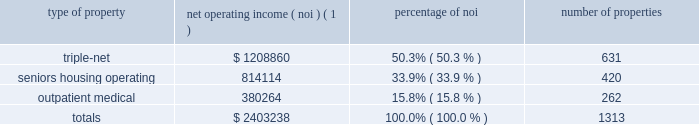Item 7 .
Management 2019s discussion and analysis of financial condition and results of operations the following discussion and analysis is based primarily on the consolidated financial statements of welltower inc .
For the periods presented and should be read together with the notes thereto contained in this annual report on form 10-k .
Other important factors are identified in 201citem 1 2014 business 201d and 201citem 1a 2014 risk factors 201d above .
Executive summary company overview welltower inc .
( nyse : hcn ) , an s&p 500 company headquartered in toledo , ohio , is driving the transformation of health care infrastructure .
The company invests with leading seniors housing operators , post- acute providers and health systems to fund the real estate and infrastructure needed to scale innovative care delivery models and improve people 2019s wellness and overall health care experience .
Welltowertm , a real estate investment trust ( 201creit 201d ) , owns interests in properties concentrated in major , high-growth markets in the united states , canada and the united kingdom , consisting of seniors housing and post-acute communities and outpatient medical properties .
Our capital programs , when combined with comprehensive planning , development and property management services , make us a single-source solution for acquiring , planning , developing , managing , repositioning and monetizing real estate assets .
The table summarizes our consolidated portfolio for the year ended december 31 , 2016 ( dollars in thousands ) : type of property net operating income ( noi ) ( 1 ) percentage of number of properties .
( 1 ) excludes our share of investments in unconsolidated entities and non-segment/corporate noi .
Entities in which we have a joint venture with a minority partner are shown at 100% ( 100 % ) of the joint venture amount .
Business strategy our primary objectives are to protect stockholder capital and enhance stockholder value .
We seek to pay consistent cash dividends to stockholders and create opportunities to increase dividend payments to stockholders as a result of annual increases in net operating income and portfolio growth .
To meet these objectives , we invest across the full spectrum of seniors housing and health care real estate and diversify our investment portfolio by property type , relationship and geographic location .
Substantially all of our revenues are derived from operating lease rentals , resident fees and services , and interest earned on outstanding loans receivable .
These items represent our primary sources of liquidity to fund distributions and depend upon the continued ability of our obligors to make contractual rent and interest payments to us and the profitability of our operating properties .
To the extent that our customers/partners experience operating difficulties and become unable to generate sufficient cash to make payments to us , there could be a material adverse impact on our consolidated results of operations , liquidity and/or financial condition .
To mitigate this risk , we monitor our investments through a variety of methods determined by the type of property .
Our proactive and comprehensive asset management process for seniors housing properties generally includes review of monthly financial statements and other operating data for each property , review of obligor/ partner creditworthiness , property inspections , and review of covenant compliance relating to licensure , real estate taxes , letters of credit and other collateral .
Our internal property management division actively manages and monitors the outpatient medical portfolio with a comprehensive process including review of tenant relations , lease expirations , the mix of health service providers , hospital/health system relationships , property performance .
What portion of the total properties is related to outpatient medical? 
Computations: (262 / 1313)
Answer: 0.19954. 